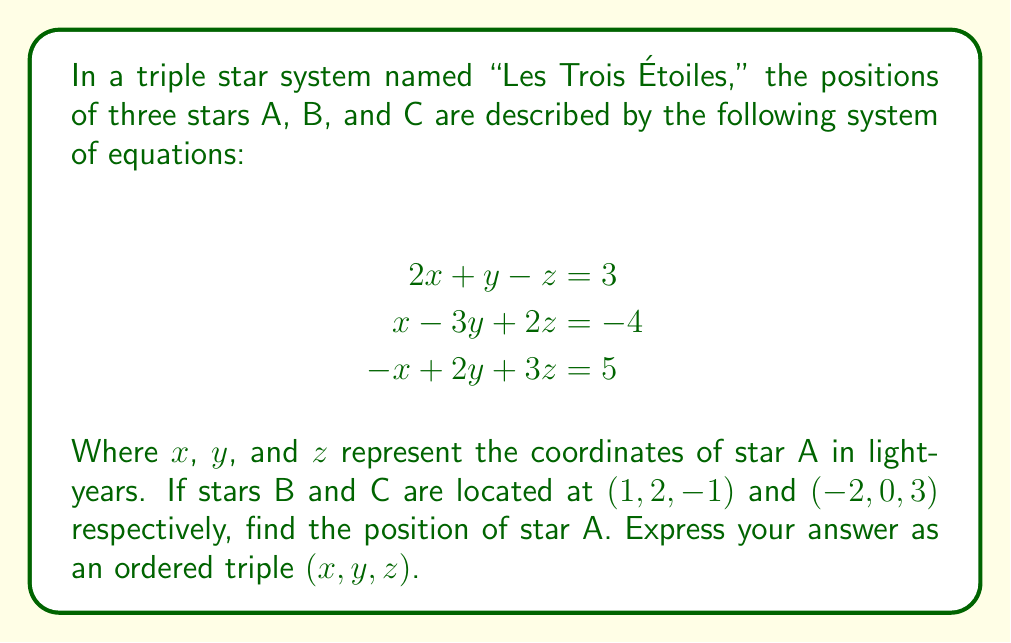Can you solve this math problem? Let's solve this système d'équations step by step:

1) First, we'll use the elimination method to solve for $x$, $y$, and $z$.

2) Multiply the first equation by 3 and the second equation by 1:
   $$\begin{align}
   6x + 3y - 3z &= 9 \\
   x - 3y + 2z &= -4
   \end{align}$$

3) Add these equations to eliminate $y$:
   $$7x - z = 5$$

4) Now, multiply the second equation by 2 and the third equation by 1:
   $$\begin{align}
   2x - 6y + 4z &= -8 \\
   -x + 2y + 3z &= 5
   \end{align}$$

5) Add these equations to eliminate $x$:
   $$-4y + 7z = -3$$

6) We now have two equations with two unknowns:
   $$\begin{align}
   7x - z &= 5 \\
   -4y + 7z &= -3
   \end{align}$$

7) From the first equation: $x = \frac{5+z}{7}$

8) Substitute this into the original first equation:
   $$2(\frac{5+z}{7}) + y - z = 3$$
   $$\frac{10+2z}{7} + y - z = 3$$
   $$10 + 2z + 7y - 7z = 21$$
   $$7y - 5z = 11$$

9) Now we have:
   $$\begin{align}
   7y - 5z &= 11 \\
   -4y + 7z &= -3
   \end{align}$$

10) Multiply the first equation by 4 and the second by 7:
    $$\begin{align}
    28y - 20z &= 44 \\
    -28y + 49z &= -21
    \end{align}$$

11) Add these equations:
    $$29z = 23$$
    $$z = \frac{23}{29}$$

12) Substitute this back into $7y - 5z = 11$:
    $$7y - 5(\frac{23}{29}) = 11$$
    $$7y = 11 + \frac{115}{29} = \frac{434}{29}$$
    $$y = \frac{62}{29}$$

13) Finally, substitute $z$ into $x = \frac{5+z}{7}$:
    $$x = \frac{5+\frac{23}{29}}{7} = \frac{168}{203}$$

Therefore, the coordinates of star A are $(\frac{168}{203}, \frac{62}{29}, \frac{23}{29})$.
Answer: $(\frac{168}{203}, \frac{62}{29}, \frac{23}{29})$ 